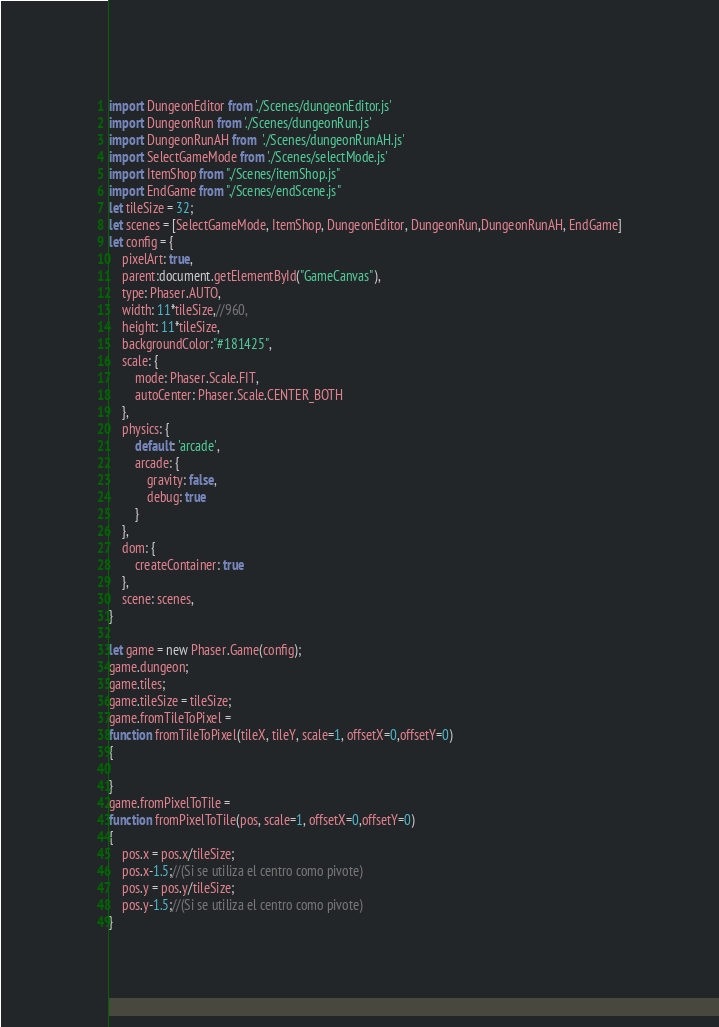<code> <loc_0><loc_0><loc_500><loc_500><_JavaScript_>import DungeonEditor from './Scenes/dungeonEditor.js'
import DungeonRun from './Scenes/dungeonRun.js'
import DungeonRunAH from  './Scenes/dungeonRunAH.js'
import SelectGameMode from './Scenes/selectMode.js'
import ItemShop from "./Scenes/itemShop.js"
import EndGame from "./Scenes/endScene.js"
let tileSize = 32;
let scenes = [SelectGameMode, ItemShop, DungeonEditor, DungeonRun,DungeonRunAH, EndGame]
let config = {
    pixelArt: true,
    parent:document.getElementById("GameCanvas"),
    type: Phaser.AUTO,
    width: 11*tileSize,//960,
    height: 11*tileSize,
    backgroundColor:"#181425",
    scale: {
        mode: Phaser.Scale.FIT,
        autoCenter: Phaser.Scale.CENTER_BOTH
    },
    physics: {
        default: 'arcade',
        arcade: {
            gravity: false,
            debug: true
        }
    },
    dom: {
        createContainer: true
    },
    scene: scenes,
}

let game = new Phaser.Game(config);
game.dungeon;
game.tiles;
game.tileSize = tileSize;
game.fromTileToPixel = 
function fromTileToPixel(tileX, tileY, scale=1, offsetX=0,offsetY=0)
{

}
game.fromPixelToTile = 
function fromPixelToTile(pos, scale=1, offsetX=0,offsetY=0)
{
    pos.x = pos.x/tileSize;
    pos.x-1.5;//(Si se utiliza el centro como pivote)
    pos.y = pos.y/tileSize;
    pos.y-1.5;//(Si se utiliza el centro como pivote)
}


</code> 